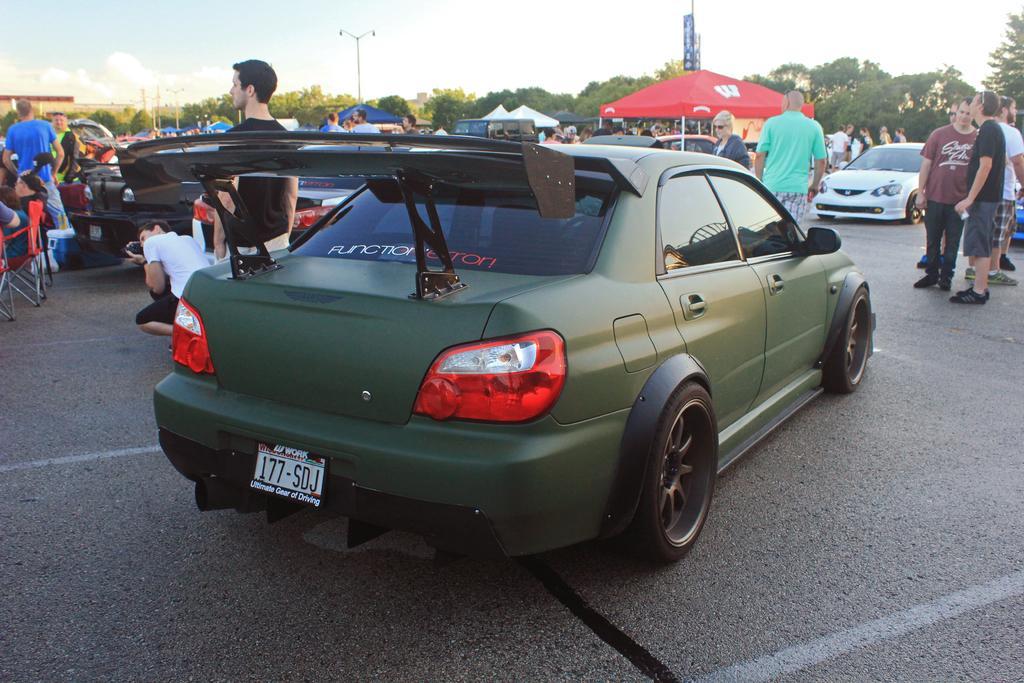Please provide a concise description of this image. In this image, we can see a car is parked on the road. Background we can see a group of people, vehicles, stalls, trees, poles, banners, few objects and sky. On the left side of the image, we can see a person is holding a camera. 